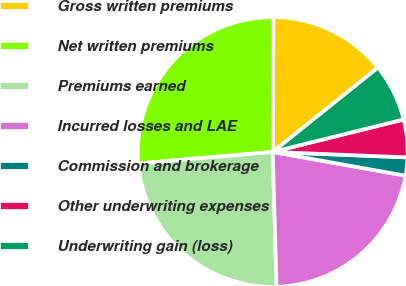Convert chart to OTSL. <chart><loc_0><loc_0><loc_500><loc_500><pie_chart><fcel>Gross written premiums<fcel>Net written premiums<fcel>Premiums earned<fcel>Incurred losses and LAE<fcel>Commission and brokerage<fcel>Other underwriting expenses<fcel>Underwriting gain (loss)<nl><fcel>14.17%<fcel>26.44%<fcel>24.09%<fcel>21.73%<fcel>2.17%<fcel>4.52%<fcel>6.88%<nl></chart> 